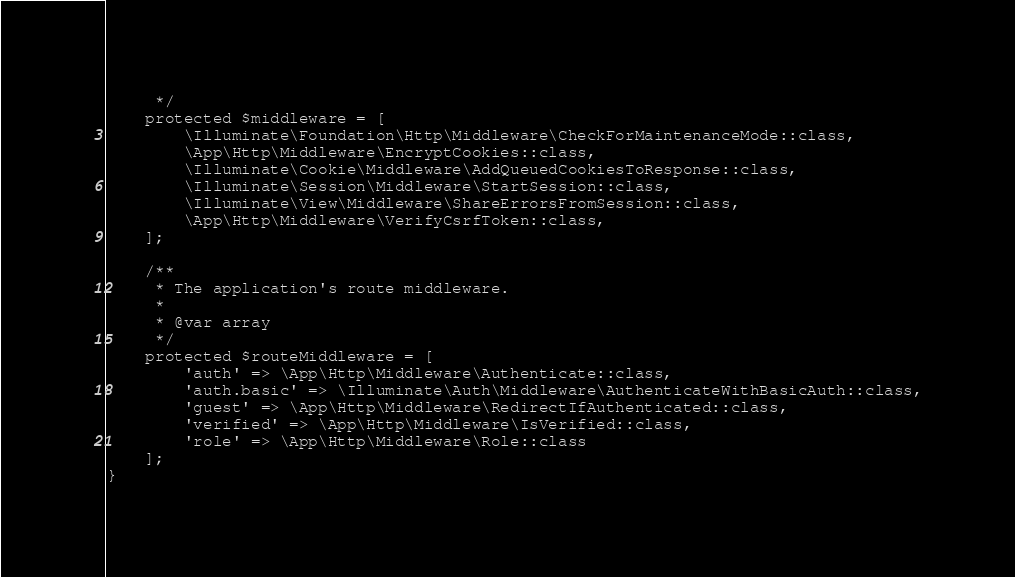Convert code to text. <code><loc_0><loc_0><loc_500><loc_500><_PHP_>     */
    protected $middleware = [
        \Illuminate\Foundation\Http\Middleware\CheckForMaintenanceMode::class,
        \App\Http\Middleware\EncryptCookies::class,
        \Illuminate\Cookie\Middleware\AddQueuedCookiesToResponse::class,
        \Illuminate\Session\Middleware\StartSession::class,
        \Illuminate\View\Middleware\ShareErrorsFromSession::class,
        \App\Http\Middleware\VerifyCsrfToken::class,
    ];

    /**
     * The application's route middleware.
     *
     * @var array
     */
    protected $routeMiddleware = [
        'auth' => \App\Http\Middleware\Authenticate::class,
        'auth.basic' => \Illuminate\Auth\Middleware\AuthenticateWithBasicAuth::class,
        'guest' => \App\Http\Middleware\RedirectIfAuthenticated::class,
        'verified' => \App\Http\Middleware\IsVerified::class,
        'role' => \App\Http\Middleware\Role::class
    ];
}
</code> 